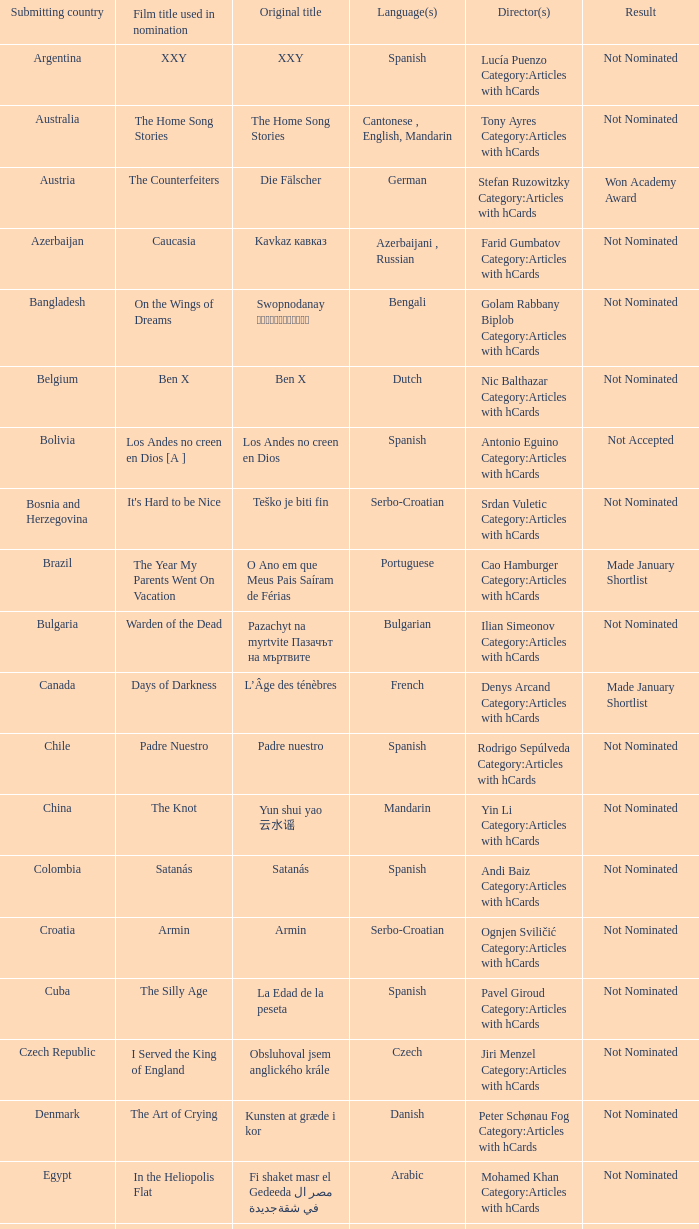What country submitted miehen työ? Finland. Could you help me parse every detail presented in this table? {'header': ['Submitting country', 'Film title used in nomination', 'Original title', 'Language(s)', 'Director(s)', 'Result'], 'rows': [['Argentina', 'XXY', 'XXY', 'Spanish', 'Lucía Puenzo Category:Articles with hCards', 'Not Nominated'], ['Australia', 'The Home Song Stories', 'The Home Song Stories', 'Cantonese , English, Mandarin', 'Tony Ayres Category:Articles with hCards', 'Not Nominated'], ['Austria', 'The Counterfeiters', 'Die Fälscher', 'German', 'Stefan Ruzowitzky Category:Articles with hCards', 'Won Academy Award'], ['Azerbaijan', 'Caucasia', 'Kavkaz кавказ', 'Azerbaijani , Russian', 'Farid Gumbatov Category:Articles with hCards', 'Not Nominated'], ['Bangladesh', 'On the Wings of Dreams', 'Swopnodanay স্বপ্নডানায়', 'Bengali', 'Golam Rabbany Biplob Category:Articles with hCards', 'Not Nominated'], ['Belgium', 'Ben X', 'Ben X', 'Dutch', 'Nic Balthazar Category:Articles with hCards', 'Not Nominated'], ['Bolivia', 'Los Andes no creen en Dios [A ]', 'Los Andes no creen en Dios', 'Spanish', 'Antonio Eguino Category:Articles with hCards', 'Not Accepted'], ['Bosnia and Herzegovina', "It's Hard to be Nice", 'Teško je biti fin', 'Serbo-Croatian', 'Srdan Vuletic Category:Articles with hCards', 'Not Nominated'], ['Brazil', 'The Year My Parents Went On Vacation', 'O Ano em que Meus Pais Saíram de Férias', 'Portuguese', 'Cao Hamburger Category:Articles with hCards', 'Made January Shortlist'], ['Bulgaria', 'Warden of the Dead', 'Pazachyt na myrtvite Пазачът на мъртвите', 'Bulgarian', 'Ilian Simeonov Category:Articles with hCards', 'Not Nominated'], ['Canada', 'Days of Darkness', 'L’Âge des ténèbres', 'French', 'Denys Arcand Category:Articles with hCards', 'Made January Shortlist'], ['Chile', 'Padre Nuestro', 'Padre nuestro', 'Spanish', 'Rodrigo Sepúlveda Category:Articles with hCards', 'Not Nominated'], ['China', 'The Knot', 'Yun shui yao 云水谣', 'Mandarin', 'Yin Li Category:Articles with hCards', 'Not Nominated'], ['Colombia', 'Satanás', 'Satanás', 'Spanish', 'Andi Baiz Category:Articles with hCards', 'Not Nominated'], ['Croatia', 'Armin', 'Armin', 'Serbo-Croatian', 'Ognjen Sviličić Category:Articles with hCards', 'Not Nominated'], ['Cuba', 'The Silly Age', 'La Edad de la peseta', 'Spanish', 'Pavel Giroud Category:Articles with hCards', 'Not Nominated'], ['Czech Republic', 'I Served the King of England', 'Obsluhoval jsem anglického krále', 'Czech', 'Jiri Menzel Category:Articles with hCards', 'Not Nominated'], ['Denmark', 'The Art of Crying', 'Kunsten at græde i kor', 'Danish', 'Peter Schønau Fog Category:Articles with hCards', 'Not Nominated'], ['Egypt', 'In the Heliopolis Flat', 'Fi shaket masr el Gedeeda في شقة مصر الجديدة', 'Arabic', 'Mohamed Khan Category:Articles with hCards', 'Not Nominated'], ['Estonia', 'The Class', 'Klass', 'Estonian', 'Ilmar Raag Category:Articles with hCards', 'Not Nominated'], ['Finland', "A Man's Job", 'Miehen työ', 'Finnish', 'Aleksi Salmenperä Category:Articles with hCards', 'Not Nominated'], ['Georgia', 'The Russian Triangle', 'Rusuli samkudhedi Русский треугольник', 'Russian', 'Aleko Tsabadze Category:Articles with hCards', 'Not Nominated'], ['Germany', 'The Edge of Heaven', 'Auf der anderen Seite', 'German, Turkish', 'Fatih Akin Category:Articles with hCards', 'Not Nominated'], ['Greece', 'Eduart', 'Eduart', 'Albanian , German, Greek', 'Angeliki Antoniou Category:Articles with hCards', 'Not Nominated'], ['Hong Kong', 'Exiled', 'Fong juk 放逐', 'Cantonese', 'Johnnie To Category:Articles with hCards', 'Not Nominated'], ['Hungary', 'Taxidermia', 'Taxidermia', 'Hungarian', 'György Pálfi Category:Articles with hCards', 'Not Nominated'], ['Iceland', 'Jar City', 'Mýrin', 'Icelandic', 'Baltasar Kormakur Category:Articles with hCards', 'Not Nominated'], ['India', 'Eklavya: The Royal Guard [B ]', 'Eklavya: The Royal Guard एकलव्य', 'Hindi', 'Vidhu Vinod Chopra Category:Articles with hCards', 'Not Nominated'], ['Indonesia', 'Denias, Singing on the Cloud', 'Denias Senandung Di Atas Awan', 'Indonesian', 'John De Rantau Category:Articles with hCards', 'Not Nominated'], ['Iran', 'M for Mother', 'Mim Mesle Madar میم مثل مادر', 'Persian', 'Rasul Mollagholipour Category:Articles with hCards', 'Not Nominated'], ['Iraq', 'Jani Gal', 'Jani Gal', 'Kurdish', 'Jamil Rostami Category:Articles with hCards', 'Not Nominated'], ['Ireland', 'Kings', 'Kings', 'Irish, English', 'Tommy Collins Category:Articles with hCards', 'Not Nominated'], ['Israel', 'Beaufort [C ]', 'Beaufort בופור', 'Hebrew', 'Joseph Cedar Category:Articles with hCards', 'Nominee'], ['Italy', 'La sconosciuta', 'La sconosciuta', 'Italian', 'Giuseppe Tornatore Category:Articles with hCards', 'Made January Shortlist'], ['Japan', "I Just Didn't Do It", 'Soredemo boku wa yatte nai ( それでもボクはやってない ? )', 'Japanese', 'Masayuki Suo Category:Articles with hCards', 'Not Nominated'], ['Kazakhstan', 'Mongol', 'Mongol Монгол', 'Mongolian', 'Sergei Bodrov Category:Articles with hCards', 'Nominee'], ['Lebanon', 'Caramel', 'Sukkar banat سكر بنات', 'Arabic, French', 'Nadine Labaki Category:Articles with hCards', 'Not Nominated'], ['Luxembourg', 'Little Secrets', 'Perl oder Pica', 'Luxembourgish', 'Pol Cruchten Category:Articles with hCards', 'Not Nominated'], ['Macedonia', 'Shadows', 'Senki Сенки', 'Macedonian', 'Milčo Mančevski Category:Articles with hCards', 'Not Nominated'], ['Mexico', 'Silent Light', 'Stellet licht', 'Plautdietsch', 'Carlos Reygadas Category:Articles with hCards', 'Not Nominated'], ['Netherlands', 'Duska', 'Duska', 'Dutch', 'Jos Stelling Category:Articles with hCards', 'Not Nominated'], ['Norway', 'Gone with the Woman', 'Tatt av Kvinnen', 'Norwegian', 'Petter Naess Category:Articles with hCards', 'Not Nominated'], ['Peru', 'Crossing a Shadow', 'Una sombra al frente', 'Spanish', 'Augusto Tamayo Category:Articles with hCards', 'Not Nominated'], ['Philippines', 'Donsol', 'Donsol', 'Bikol , Tagalog', 'Adolfo Alix, Jr. Category:Articles with hCards', 'Not Nominated'], ['Poland', 'Katyń', 'Katyń', 'Polish', 'Andrzej Wajda Category:Articles with hCards', 'Nominee'], ['Portugal', 'Belle Toujours', 'Belle Toujours', 'French', 'Manoel de Oliveira Category:Articles with hCards', 'Not Nominated'], ['Romania', '4 Months, 3 Weeks and 2 Days', '4 luni, 3 săptămâni şi 2 zile', 'Romanian', 'Cristian Mungiu Category:Articles with hCards', 'Not Nominated'], ['Russia', '12', '12', 'Russian, Chechen', 'Nikita Mikhalkov Category:Articles with hCards', 'Nominee'], ['Serbia', 'The Trap', 'Klopka Клопка', 'Serbo-Croatian', 'Srdan Golubović Category:Articles with hCards', 'Made January Shortlist'], ['Singapore', '881', '881', 'Mandarin , Hokkien', 'Royston Tan Category:Articles with hCards', 'Not Nominated'], ['Slovakia', 'Return of the Storks', 'Návrat bocianov', 'German , Slovak', 'Martin Repka Category:Articles with hCards', 'Not Nominated'], ['Slovenia', 'Short Circuits', 'Kratki stiki', 'Slovene', 'Janez Lapajne Category:Articles with hCards', 'Not Nominated'], ['South Korea', 'Secret Sunshine', 'Milyang 밀양', 'Korean', 'Lee Chang-dong Category:Articles with hCards', 'Not Nominated'], ['Spain', 'The Orphanage', 'El orfanato', 'Spanish', 'Juan Antonio Bayona Category:Articles with hCards', 'Not Nominated'], ['Sweden', 'You, the Living', 'Du levande', 'Swedish', 'Roy Andersson Category:Articles with hCards', 'Not Nominated'], ['Switzerland', 'Late Bloomers', 'Die Herbstzeitlosen', 'Swiss German', 'Bettina Oberli Category:Articles with hCards', 'Not Nominated'], ['Taiwan', 'Island Etude [D ]', 'Liànxí Qǔ 練習曲', 'Mandarin , Taiwanese', 'Chen Huai-En Category:Articles with hCards', 'Not Nominated'], ['Turkey', "A Man's Fear of God", 'Takva', 'Turkish', 'Özer Kızıltan Category:Articles with hCards', 'Not Nominated'], ['Venezuela', 'Postcards from Leningrad', 'Postales de Leningrado', 'Spanish', 'Mariana Rondon Category:Articles with hCards', 'Not Nominated']]} 